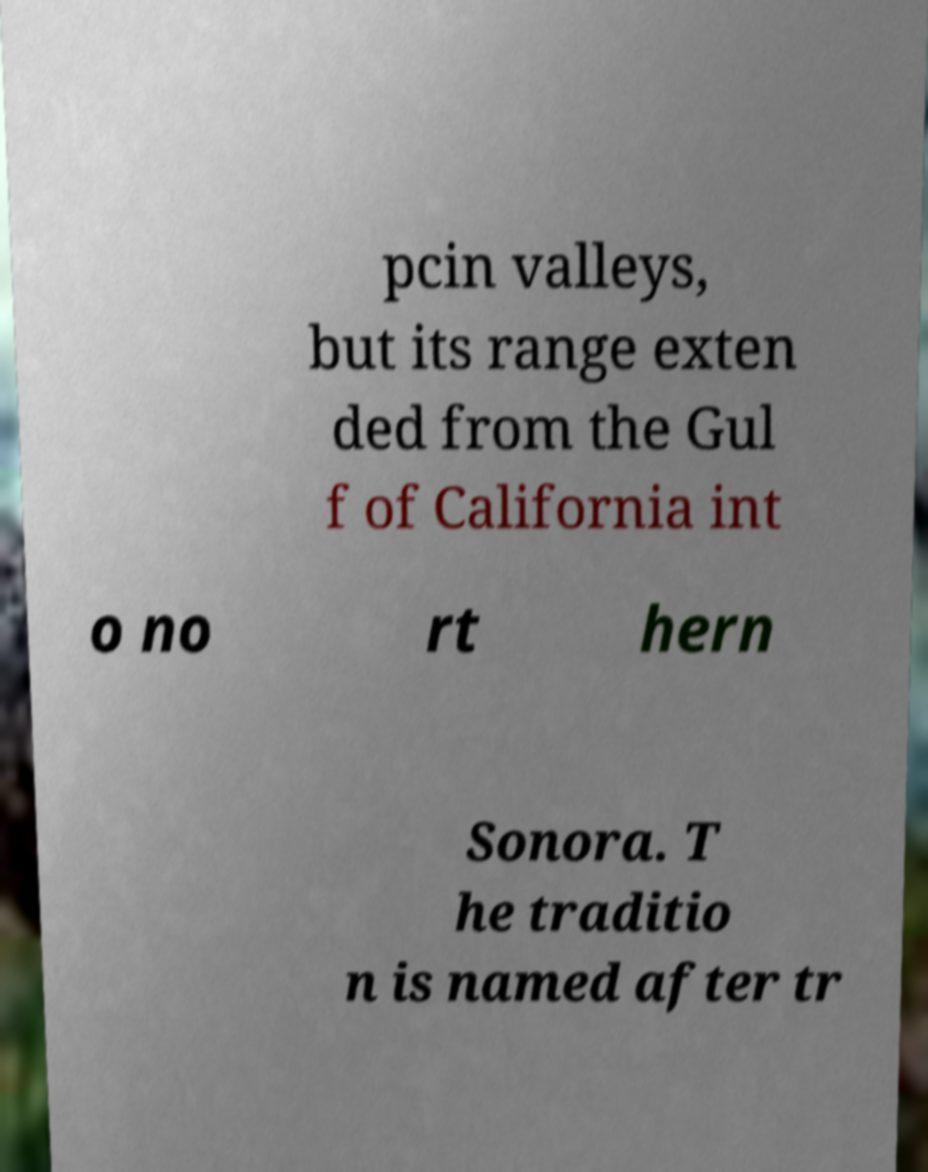I need the written content from this picture converted into text. Can you do that? pcin valleys, but its range exten ded from the Gul f of California int o no rt hern Sonora. T he traditio n is named after tr 